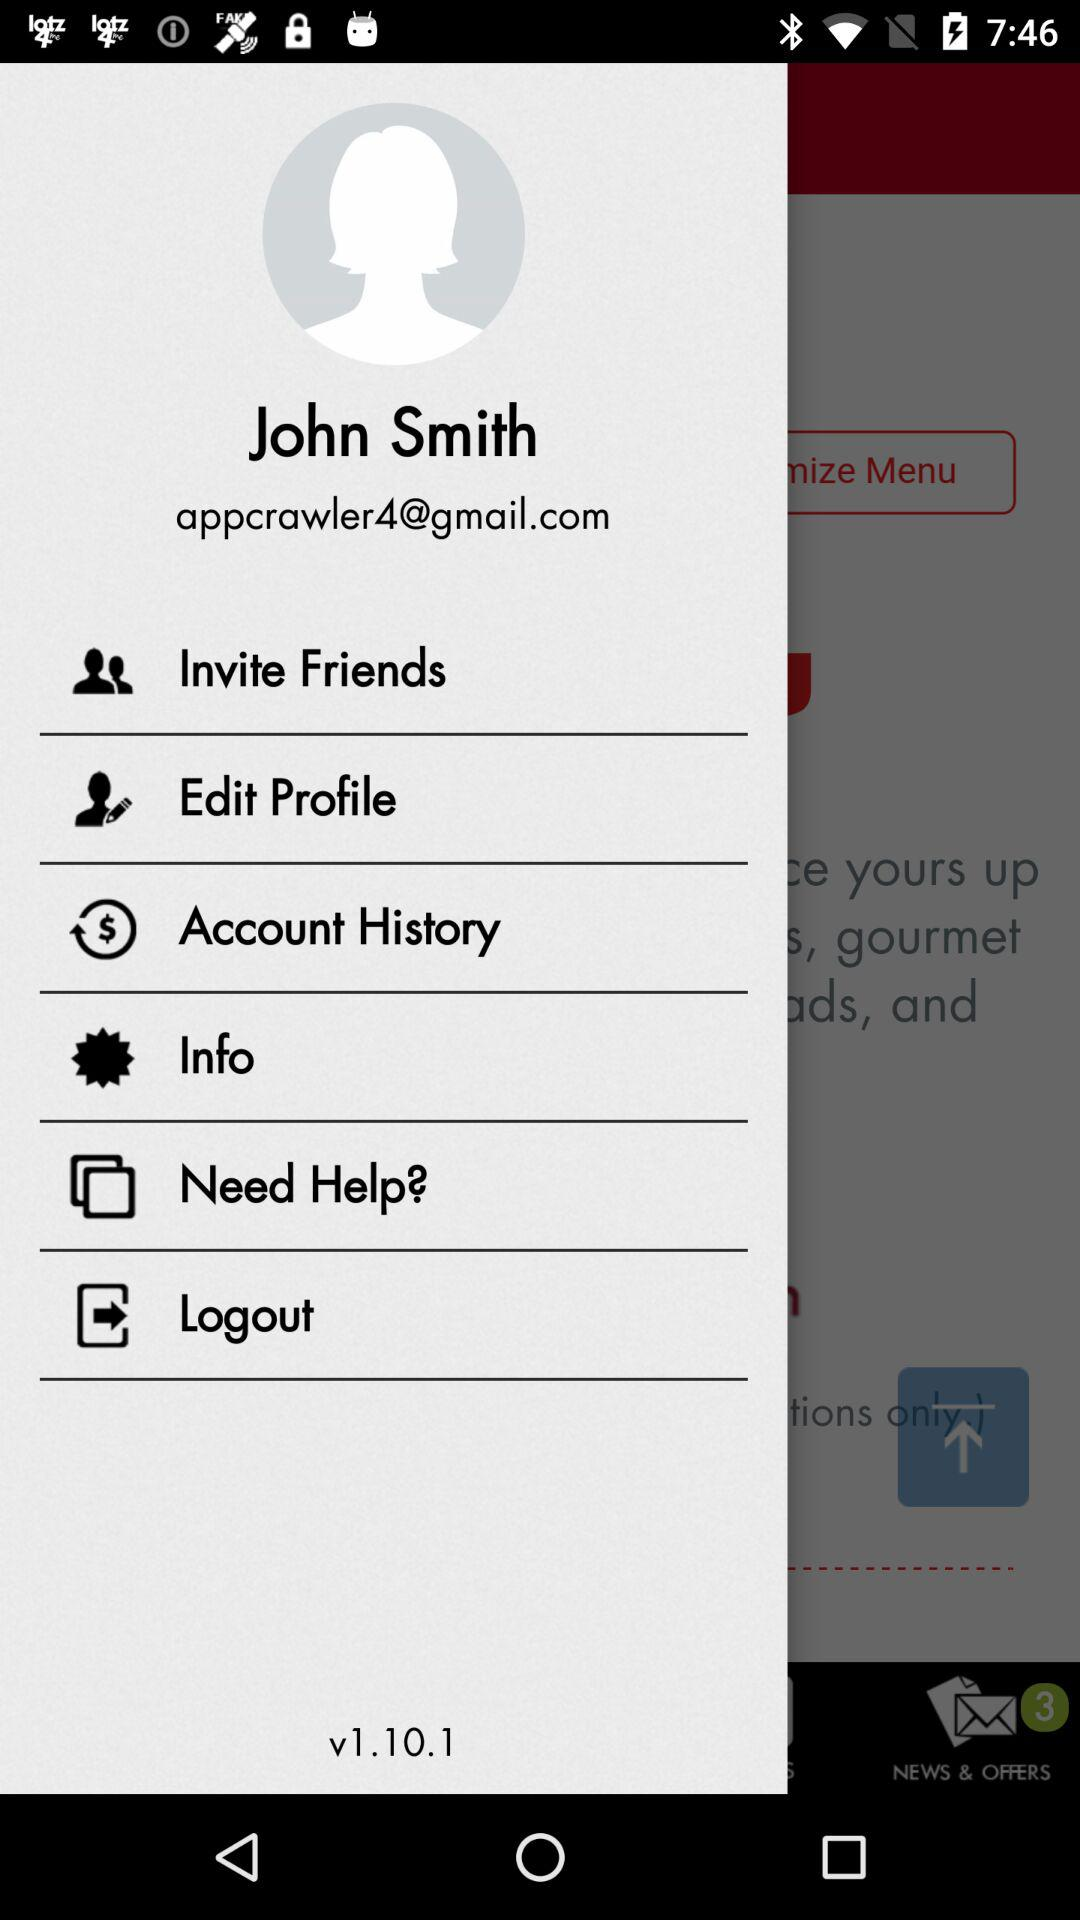What is the name of the user? The name of the user is John Smith. 